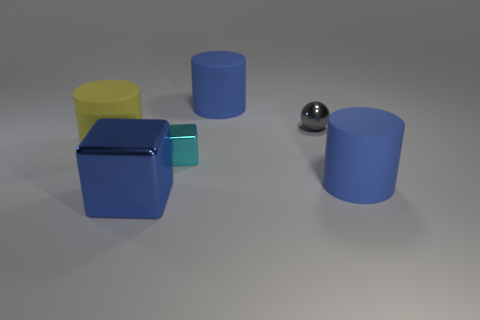What is the material of the tiny thing that is right of the large blue rubber thing behind the cylinder that is on the left side of the large metal thing?
Provide a short and direct response. Metal. The tiny thing behind the big matte cylinder left of the large metallic cube is what color?
Your answer should be compact. Gray. There is a block that is the same size as the yellow matte thing; what color is it?
Your answer should be compact. Blue. What number of tiny things are blue shiny cubes or blue objects?
Make the answer very short. 0. Are there more large blue things that are in front of the ball than small balls left of the large blue block?
Make the answer very short. Yes. How many other things are the same size as the cyan thing?
Provide a succinct answer. 1. Are the cylinder that is in front of the small cyan block and the large block made of the same material?
Your answer should be compact. No. What number of other objects are there of the same color as the small cube?
Provide a short and direct response. 0. What number of other objects are the same shape as the yellow matte object?
Your answer should be very brief. 2. There is a large thing left of the blue cube; does it have the same shape as the small metal thing that is in front of the big yellow thing?
Make the answer very short. No. 